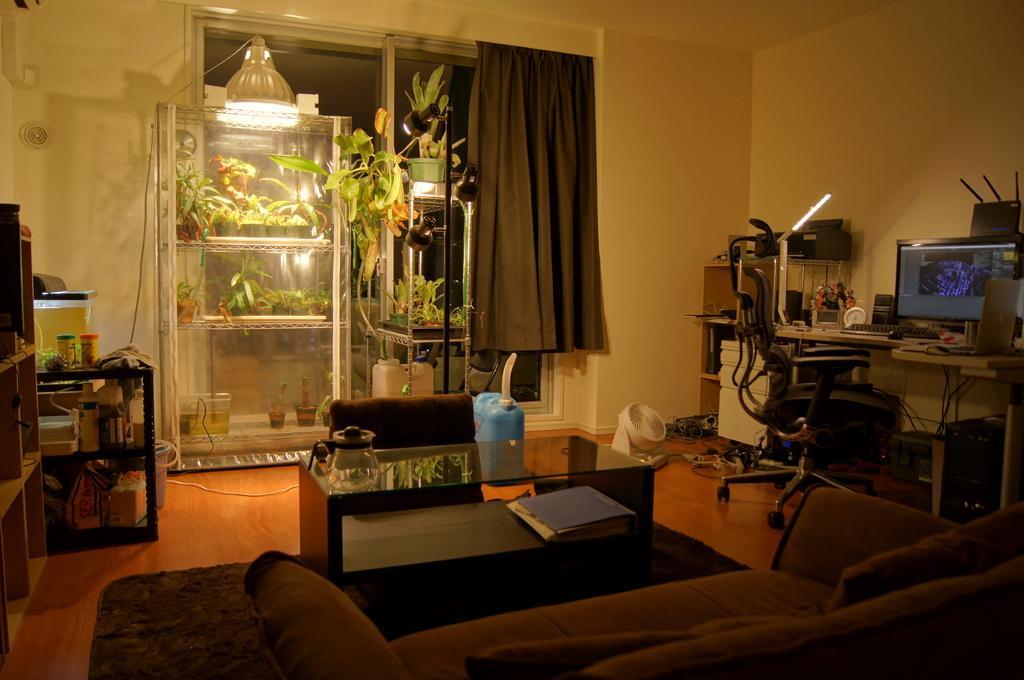Can you describe this image briefly? In this picture we can see a jug on a glass table. There is a file under the glass table. We can see a can, and other objects on the floor. There is a sofa and a carpet on the floor. We can see a chair. There is a computer, keyboard, mouse, laptop and other objects on the shelves. We can see a few houseplants in a glass container. There are a few bottles, bags, boxes and few things in a wooden object. There is a curtain in the background. 